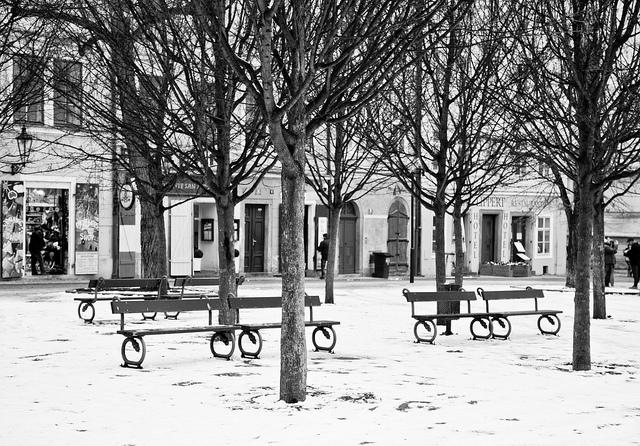What covers the ground?
Keep it brief. Snow. How many inches of snow would you guess are on the ground?
Answer briefly. 1. How many benches are there?
Short answer required. 6. Is this taken in the winter?
Write a very short answer. Yes. 